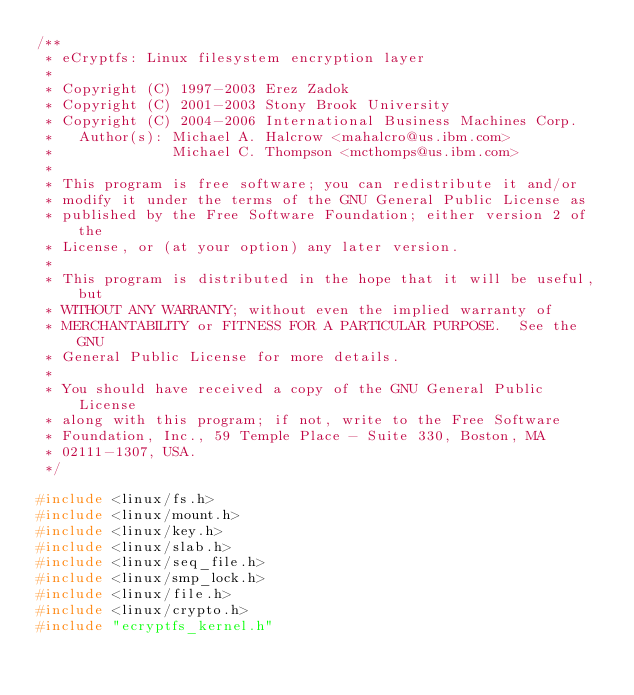Convert code to text. <code><loc_0><loc_0><loc_500><loc_500><_C_>/**
 * eCryptfs: Linux filesystem encryption layer
 *
 * Copyright (C) 1997-2003 Erez Zadok
 * Copyright (C) 2001-2003 Stony Brook University
 * Copyright (C) 2004-2006 International Business Machines Corp.
 *   Author(s): Michael A. Halcrow <mahalcro@us.ibm.com>
 *              Michael C. Thompson <mcthomps@us.ibm.com>
 *
 * This program is free software; you can redistribute it and/or
 * modify it under the terms of the GNU General Public License as
 * published by the Free Software Foundation; either version 2 of the
 * License, or (at your option) any later version.
 *
 * This program is distributed in the hope that it will be useful, but
 * WITHOUT ANY WARRANTY; without even the implied warranty of
 * MERCHANTABILITY or FITNESS FOR A PARTICULAR PURPOSE.  See the GNU
 * General Public License for more details.
 *
 * You should have received a copy of the GNU General Public License
 * along with this program; if not, write to the Free Software
 * Foundation, Inc., 59 Temple Place - Suite 330, Boston, MA
 * 02111-1307, USA.
 */

#include <linux/fs.h>
#include <linux/mount.h>
#include <linux/key.h>
#include <linux/slab.h>
#include <linux/seq_file.h>
#include <linux/smp_lock.h>
#include <linux/file.h>
#include <linux/crypto.h>
#include "ecryptfs_kernel.h"
</code> 